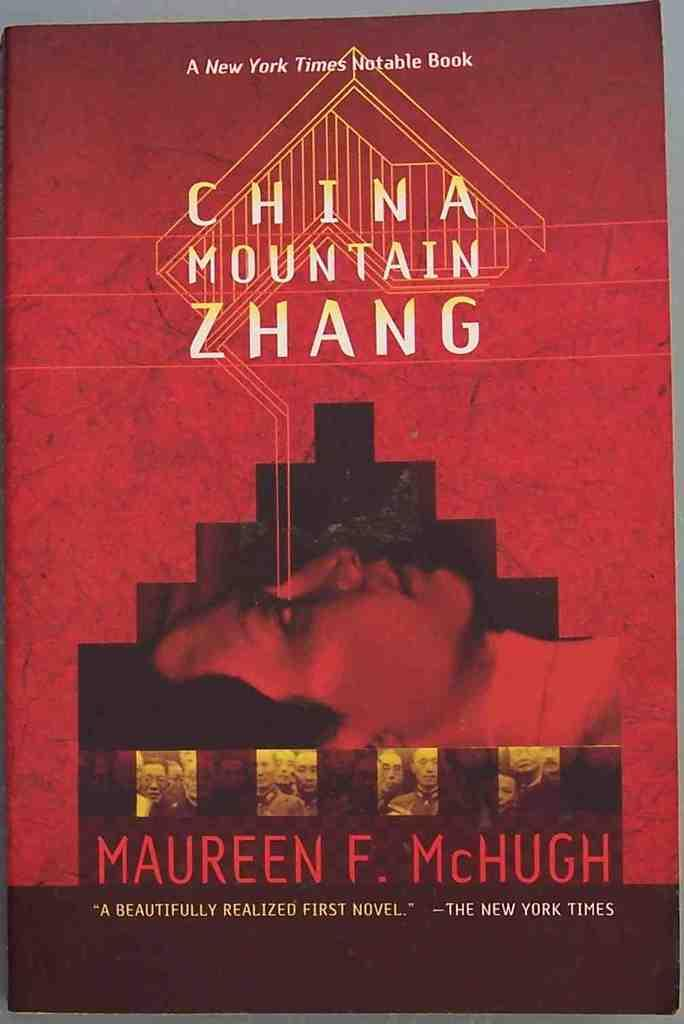<image>
Write a terse but informative summary of the picture. The cover of the book China Mountain Zhang which shows a woman's face on a red background 